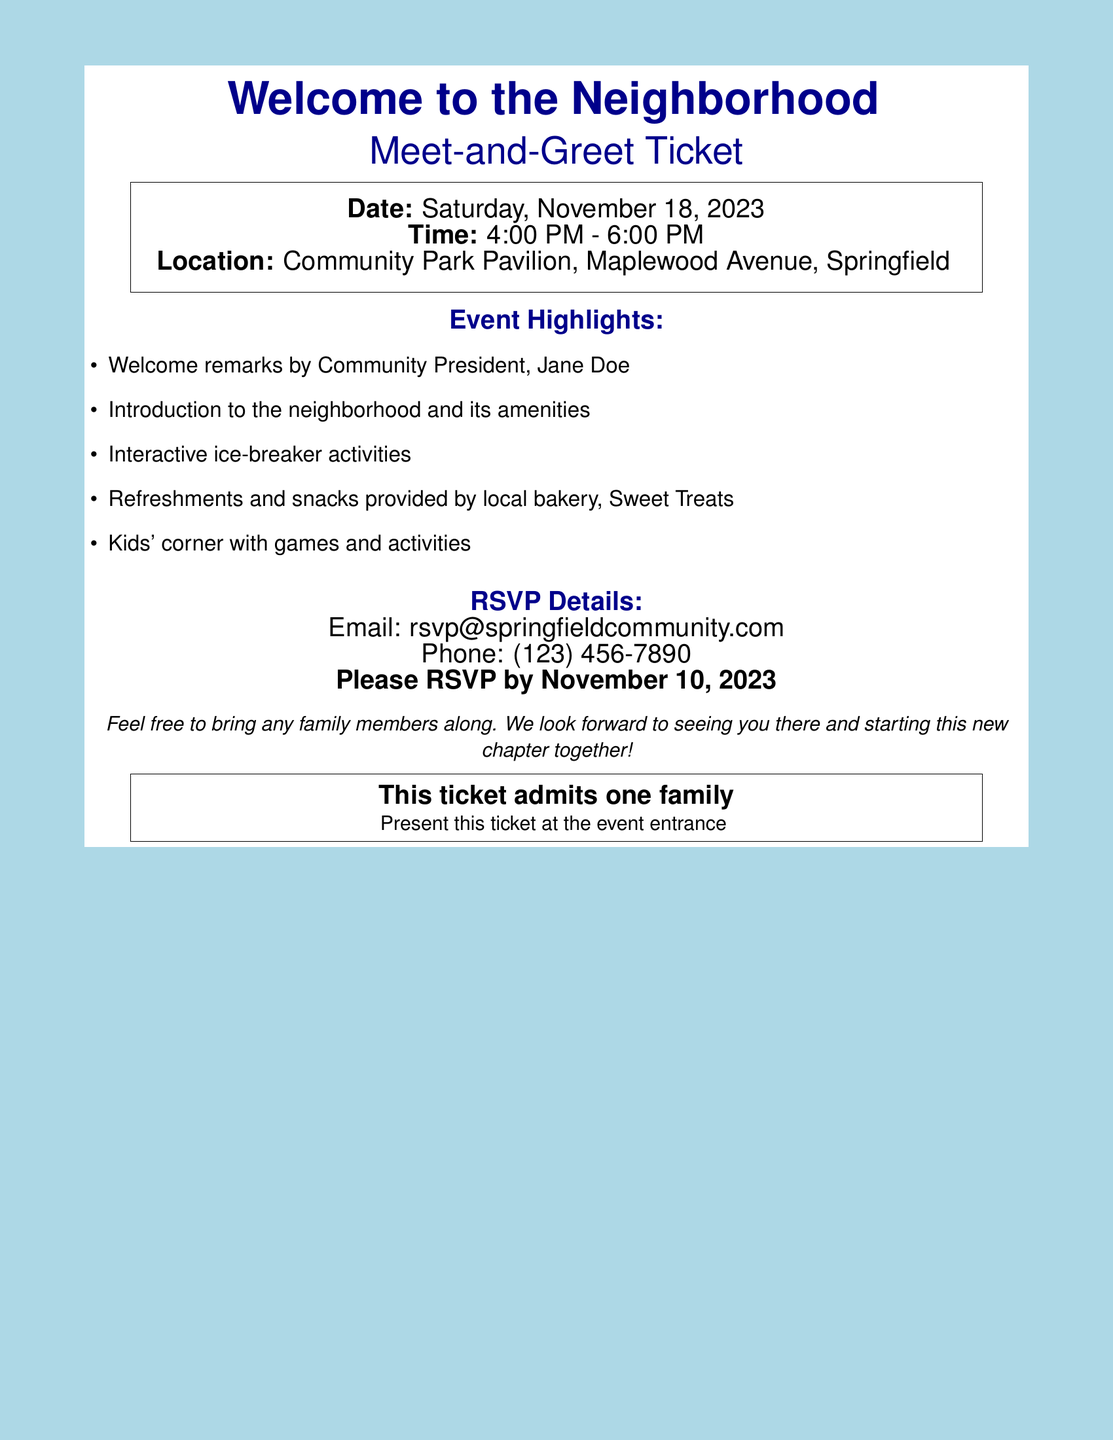what is the date of the event? The date of the event is clearly listed in the document as "Saturday, November 18, 2023."
Answer: Saturday, November 18, 2023 what is the time duration of the event? The time specified in the document shows the beginning and ending time as "4:00 PM - 6:00 PM."
Answer: 4:00 PM - 6:00 PM where is the location of the meet-and-greet? The location is mentioned as "Community Park Pavilion, Maplewood Avenue, Springfield."
Answer: Community Park Pavilion, Maplewood Avenue, Springfield who will give the welcome remarks? The document identifies the Community President, Jane Doe, as the person giving the welcome remarks.
Answer: Jane Doe what is the RSVP deadline? The document specifies that RSVPs should be completed by "November 10, 2023."
Answer: November 10, 2023 what type of activities will be included in the event? The document lists several activities, indicating that there will be "interactive ice-breaker activities."
Answer: interactive ice-breaker activities how should people RSVP? The RSVP details include an email and phone number, specifically stating to use "rsvp@springfieldcommunity.com" or "(123) 456-7890."
Answer: rsvp@springfieldcommunity.com what is stated about family members? The document mentions that attendees are welcome to "bring any family members along."
Answer: bring any family members along how many families are admitted per ticket? The document mentions that "this ticket admits one family," indicating the limit per ticket.
Answer: one family 